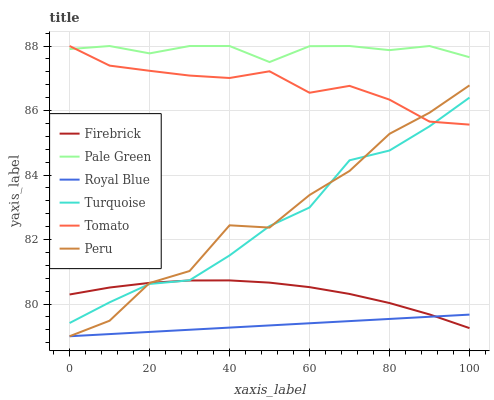Does Royal Blue have the minimum area under the curve?
Answer yes or no. Yes. Does Pale Green have the maximum area under the curve?
Answer yes or no. Yes. Does Turquoise have the minimum area under the curve?
Answer yes or no. No. Does Turquoise have the maximum area under the curve?
Answer yes or no. No. Is Royal Blue the smoothest?
Answer yes or no. Yes. Is Peru the roughest?
Answer yes or no. Yes. Is Turquoise the smoothest?
Answer yes or no. No. Is Turquoise the roughest?
Answer yes or no. No. Does Royal Blue have the lowest value?
Answer yes or no. Yes. Does Turquoise have the lowest value?
Answer yes or no. No. Does Pale Green have the highest value?
Answer yes or no. Yes. Does Turquoise have the highest value?
Answer yes or no. No. Is Royal Blue less than Tomato?
Answer yes or no. Yes. Is Turquoise greater than Royal Blue?
Answer yes or no. Yes. Does Turquoise intersect Peru?
Answer yes or no. Yes. Is Turquoise less than Peru?
Answer yes or no. No. Is Turquoise greater than Peru?
Answer yes or no. No. Does Royal Blue intersect Tomato?
Answer yes or no. No. 